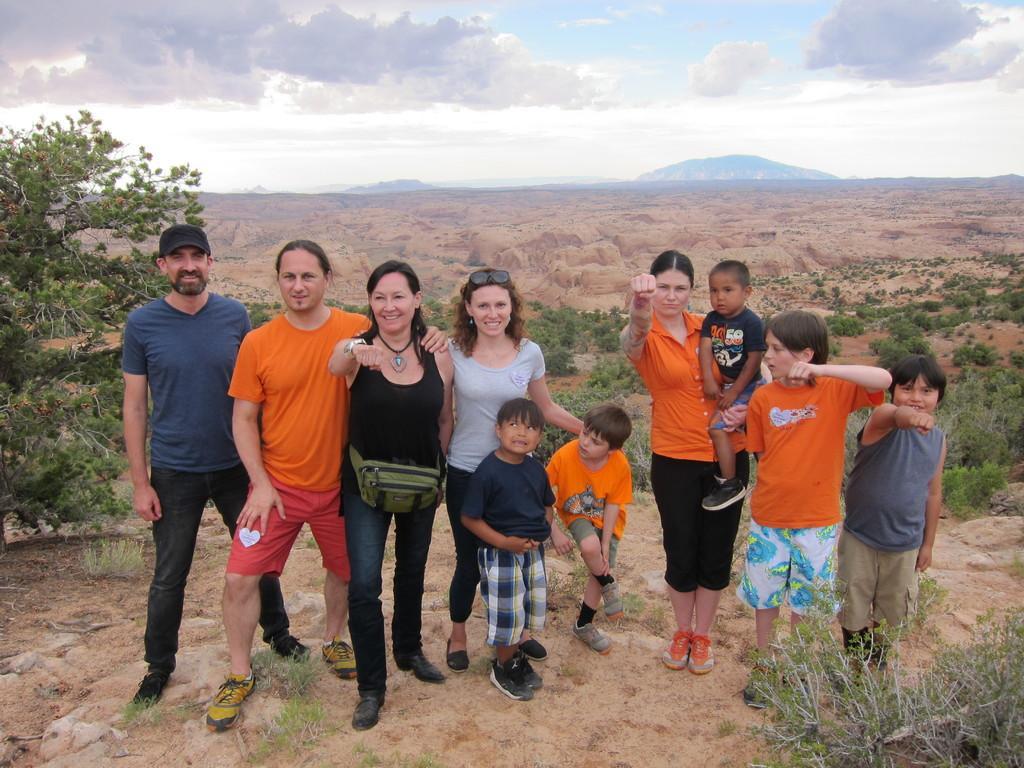Could you give a brief overview of what you see in this image? In the foreground of this image, there are men, women and kids are standing on a cliff. On the right bottom, there is a plant. In the background, there are trees, land, sky and the cloud. 